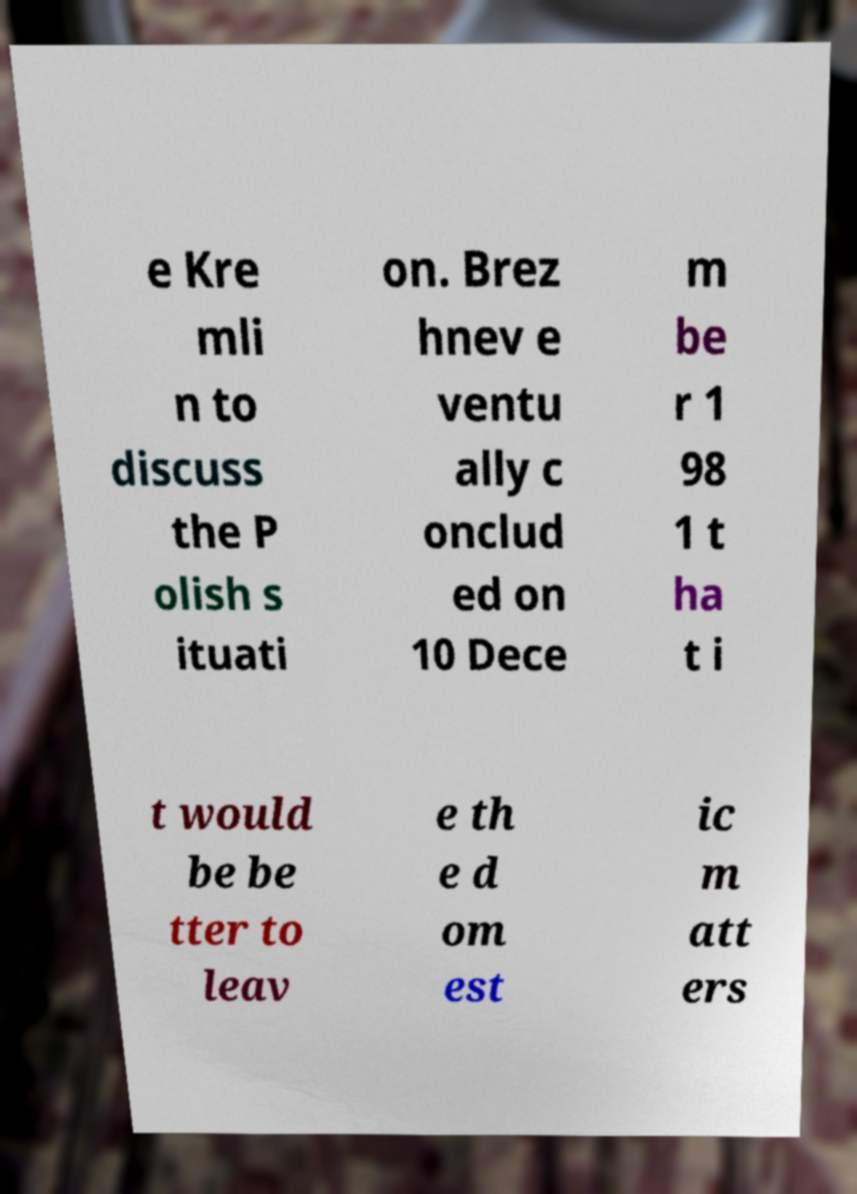Please identify and transcribe the text found in this image. e Kre mli n to discuss the P olish s ituati on. Brez hnev e ventu ally c onclud ed on 10 Dece m be r 1 98 1 t ha t i t would be be tter to leav e th e d om est ic m att ers 